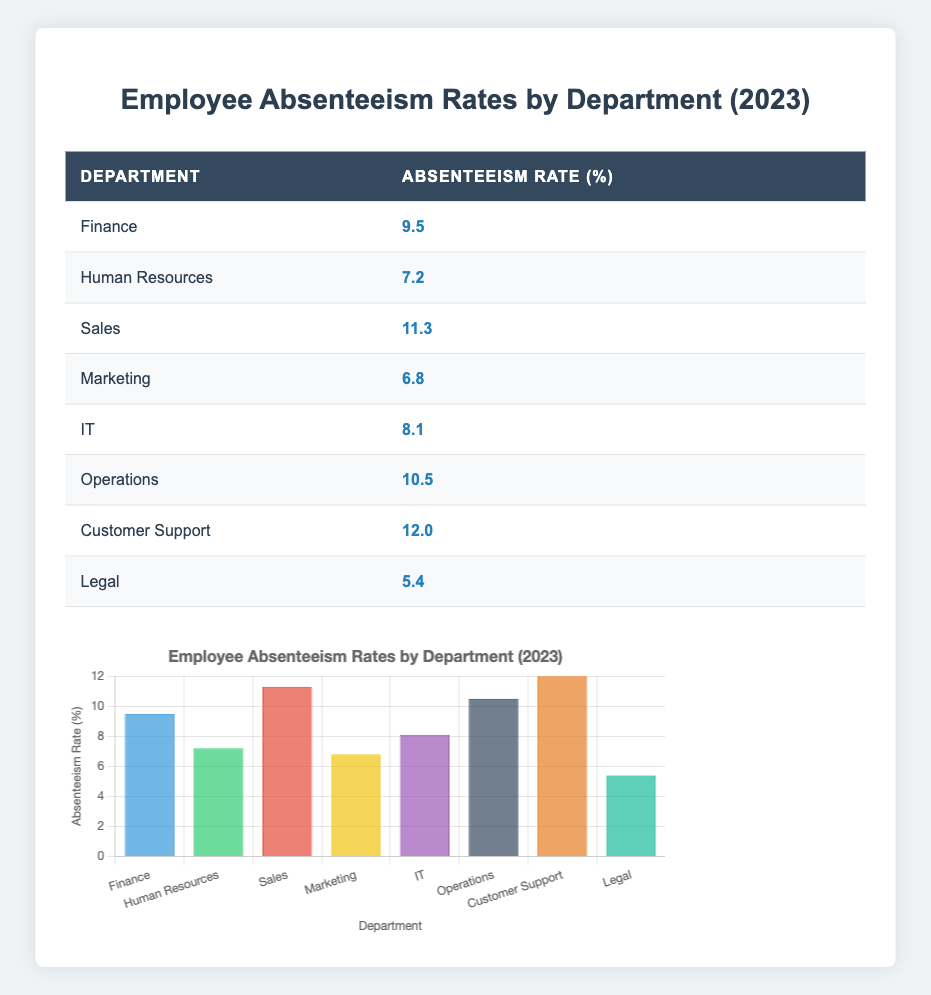What is the absenteeism rate for the IT department? To find the absenteeism rate for the IT department, simply locate the row corresponding to "IT" in the table, where the absenteeism rate is listed. According to the table, it states that the absenteeism rate for the IT department is 8.1.
Answer: 8.1 Which department has the highest absenteeism rate? The highest absenteeism rate can be identified by comparing all the rates listed in the table. After examining the rates for each department, "Customer Support" has the highest rate at 12.0.
Answer: Customer Support What is the average absenteeism rate across all departments? First, we sum the absenteeism rates of all departments: 9.5 (Finance) + 7.2 (HR) + 11.3 (Sales) + 6.8 (Marketing) + 8.1 (IT) + 10.5 (Operations) + 12.0 (Customer Support) + 5.4 (Legal) = 69.8. There are 8 departments, so we divide the total by 8: 69.8 / 8 = 8.725, which can be rounded to 8.73.
Answer: 8.73 Is the absenteeism rate for the Legal department higher than for the Marketing department? To answer this, we compare the two rates from the table. The rate for Legal is 5.4 and for Marketing is 6.8. Since 5.4 is less than 6.8, the answer is no.
Answer: No What is the absenteeism rate difference between the Sales and Human Resources departments? First, identify the absenteeism rates for both departments: Sales at 11.3 and HR at 7.2. To find the difference, subtract the HR rate from the Sales rate: 11.3 - 7.2 = 4.1.
Answer: 4.1 Which two departments have the least absenteeism rates close to each other? Reviewing the listed absenteeism rates, Marketing at 6.8 and Human Resources at 7.2 are closest together. The difference is only 0.4, which is the smallest when comparing all pairs.
Answer: Marketing and Human Resources Are there any departments with an absenteeism rate higher than 10%? We examine each department's rate in the table to see if any exceed 10%. The departments with rates above 10% are Sales at 11.3, Operations at 10.5, and Customer Support at 12.0, indicating that there are indeed departments over 10%.
Answer: Yes What is the sum of the absenteeism rates for the Finance and Operations departments? Locate the absenteeism rates for Finance (9.5) and Operations (10.5). Next, sum these two values: 9.5 + 10.5 = 20.0.
Answer: 20.0 